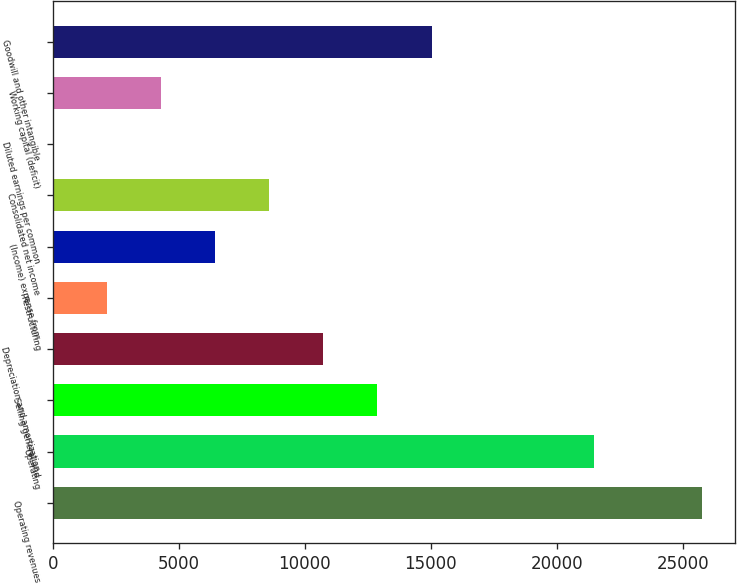Convert chart to OTSL. <chart><loc_0><loc_0><loc_500><loc_500><bar_chart><fcel>Operating revenues<fcel>Operating<fcel>Selling general and<fcel>Depreciation and amortization<fcel>Restructuring<fcel>(Income) expense from<fcel>Consolidated net income<fcel>Diluted earnings per common<fcel>Working capital (deficit)<fcel>Goodwill and other intangible<nl><fcel>25770.8<fcel>21476<fcel>12886.4<fcel>10739<fcel>2149.38<fcel>6444.18<fcel>8591.58<fcel>1.98<fcel>4296.78<fcel>15033.8<nl></chart> 